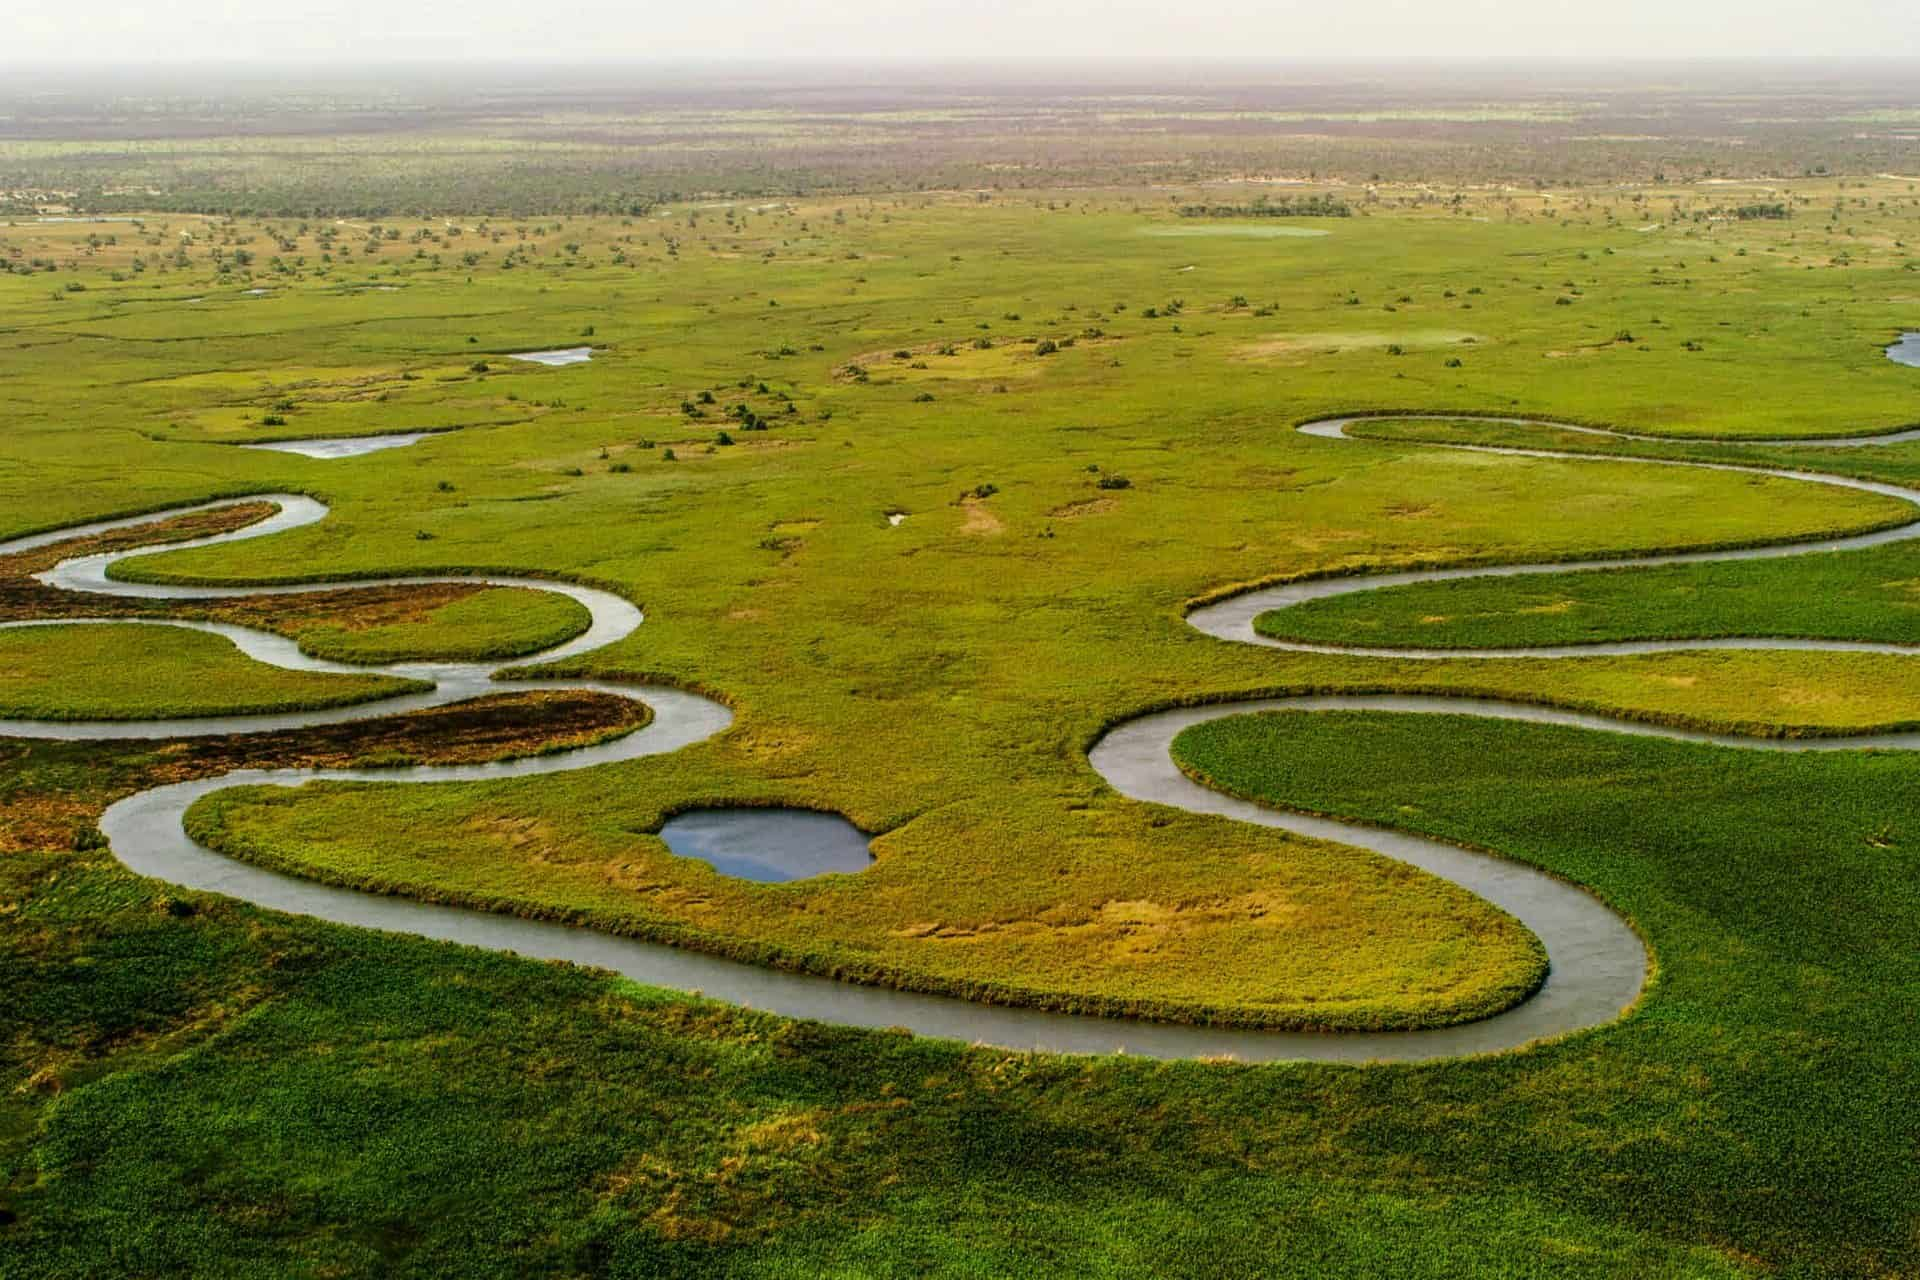Analyze the image in a comprehensive and detailed manner.
 The image captures the breathtaking view of the Okavango Delta, a vast inland river delta located in northern Botswana. From an aerial perspective, the winding waterways carve their path through the lush greenery, creating a mesmerizing pattern that is both chaotic and harmonious. The colors are predominantly green and brown, reflecting the rich vegetation and earth of the delta. The blue of the water provides a striking contrast, enhancing the overall visual impact of the scene. The horizon stretches out in the distance, adding a sense of depth and scale to the image. This bird's-eye view offers a unique glimpse into the natural beauty and complexity of this world-renowned landmark. 